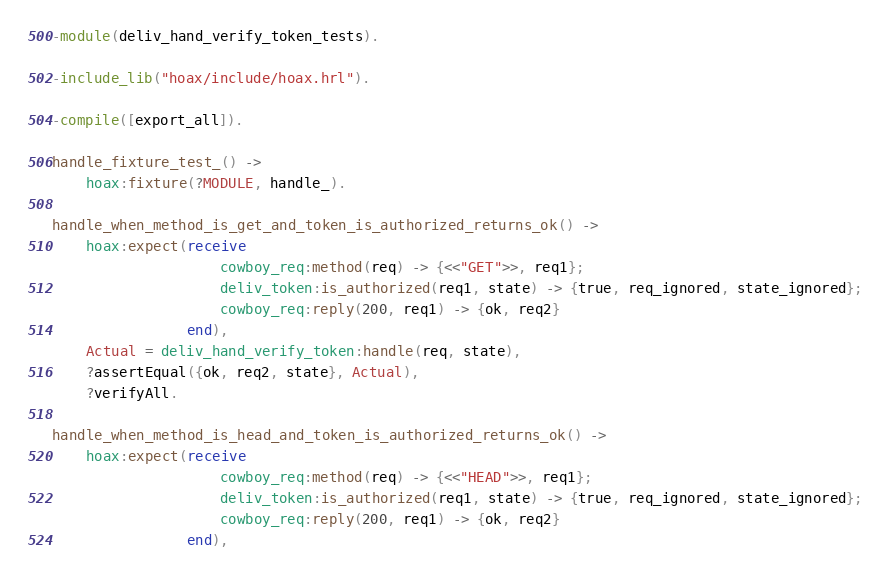<code> <loc_0><loc_0><loc_500><loc_500><_Erlang_>-module(deliv_hand_verify_token_tests).

-include_lib("hoax/include/hoax.hrl").

-compile([export_all]).

handle_fixture_test_() ->
    hoax:fixture(?MODULE, handle_).

handle_when_method_is_get_and_token_is_authorized_returns_ok() ->
    hoax:expect(receive
                    cowboy_req:method(req) -> {<<"GET">>, req1};
                    deliv_token:is_authorized(req1, state) -> {true, req_ignored, state_ignored};
                    cowboy_req:reply(200, req1) -> {ok, req2}
                end),
    Actual = deliv_hand_verify_token:handle(req, state),
    ?assertEqual({ok, req2, state}, Actual),
    ?verifyAll.

handle_when_method_is_head_and_token_is_authorized_returns_ok() ->
    hoax:expect(receive
                    cowboy_req:method(req) -> {<<"HEAD">>, req1};
                    deliv_token:is_authorized(req1, state) -> {true, req_ignored, state_ignored};
                    cowboy_req:reply(200, req1) -> {ok, req2}
                end),</code> 